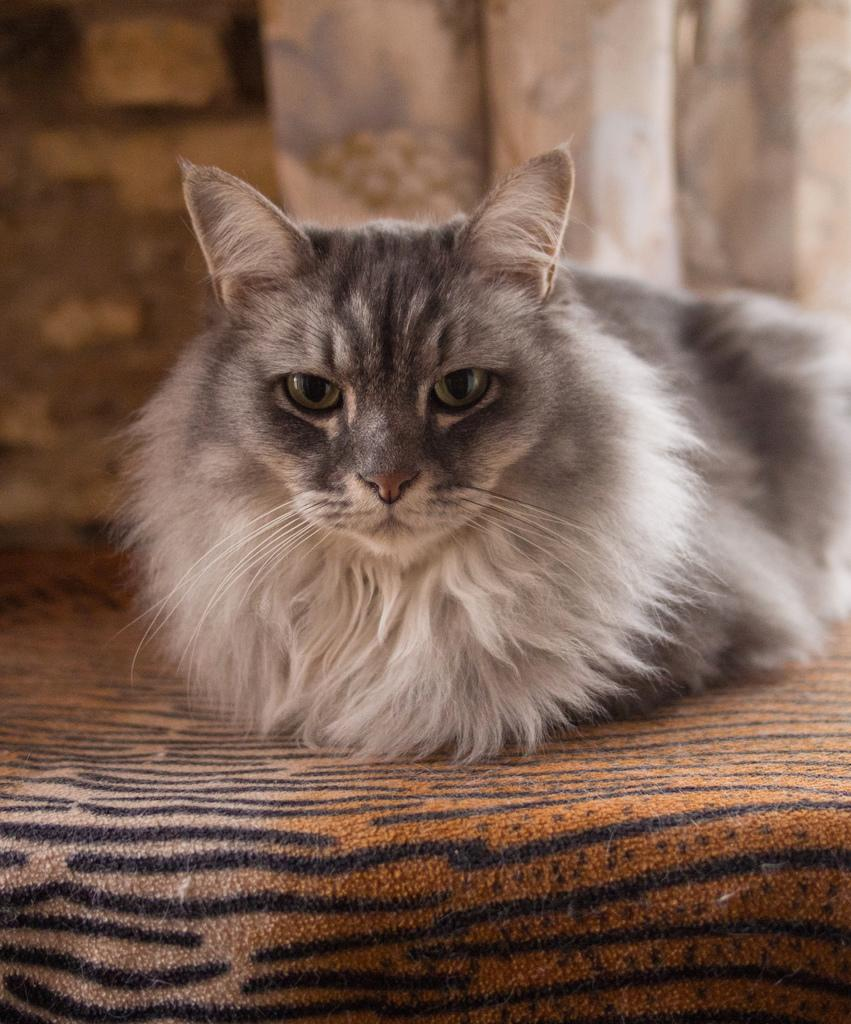What type of animal is sitting in the image? There is a cat sitting in the image. What type of window treatment is visible in the image? There are curtains visible in the image. What type of pet is the cat playing with in the image? There is no pet visible in the image, as the cat is sitting alone. What type of seasoning is present on the cat's fur in the image? There is no seasoning, such as salt, present on the cat's fur in the image. What type of button is attached to the cat's collar in the image? There is no button visible on the cat's collar in the image. 